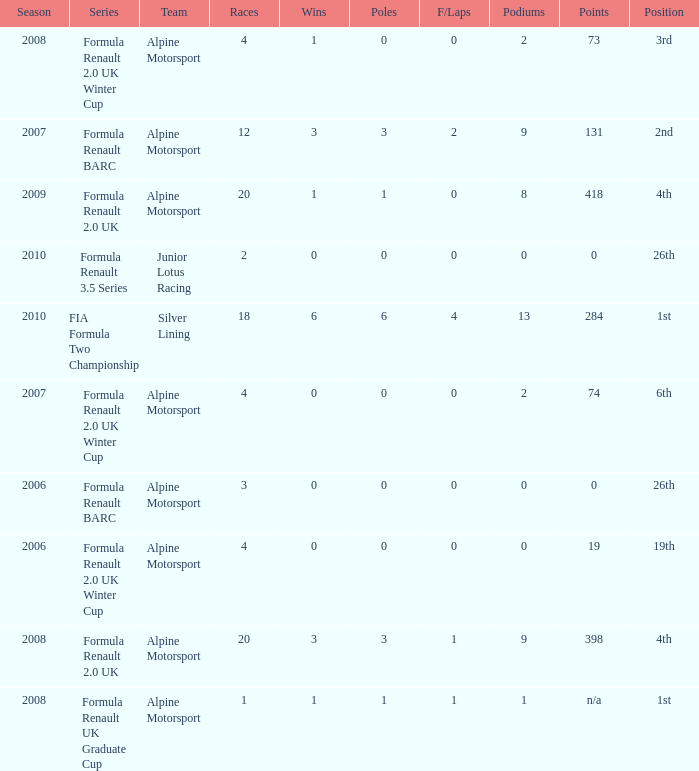How much were the f/laps if poles is higher than 1.0 during 2008? 1.0. 